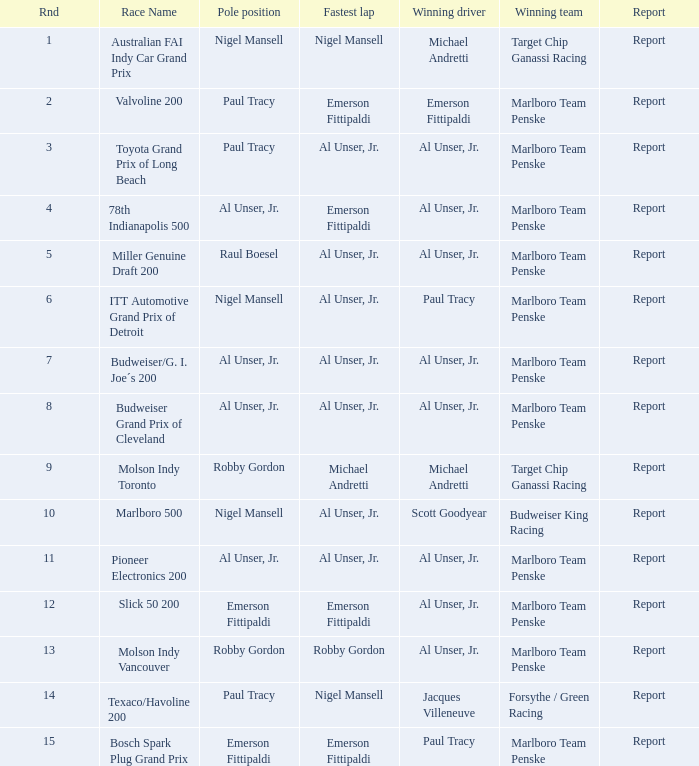Who was at the pole position in the ITT Automotive Grand Prix of Detroit, won by Paul Tracy? Nigel Mansell. 